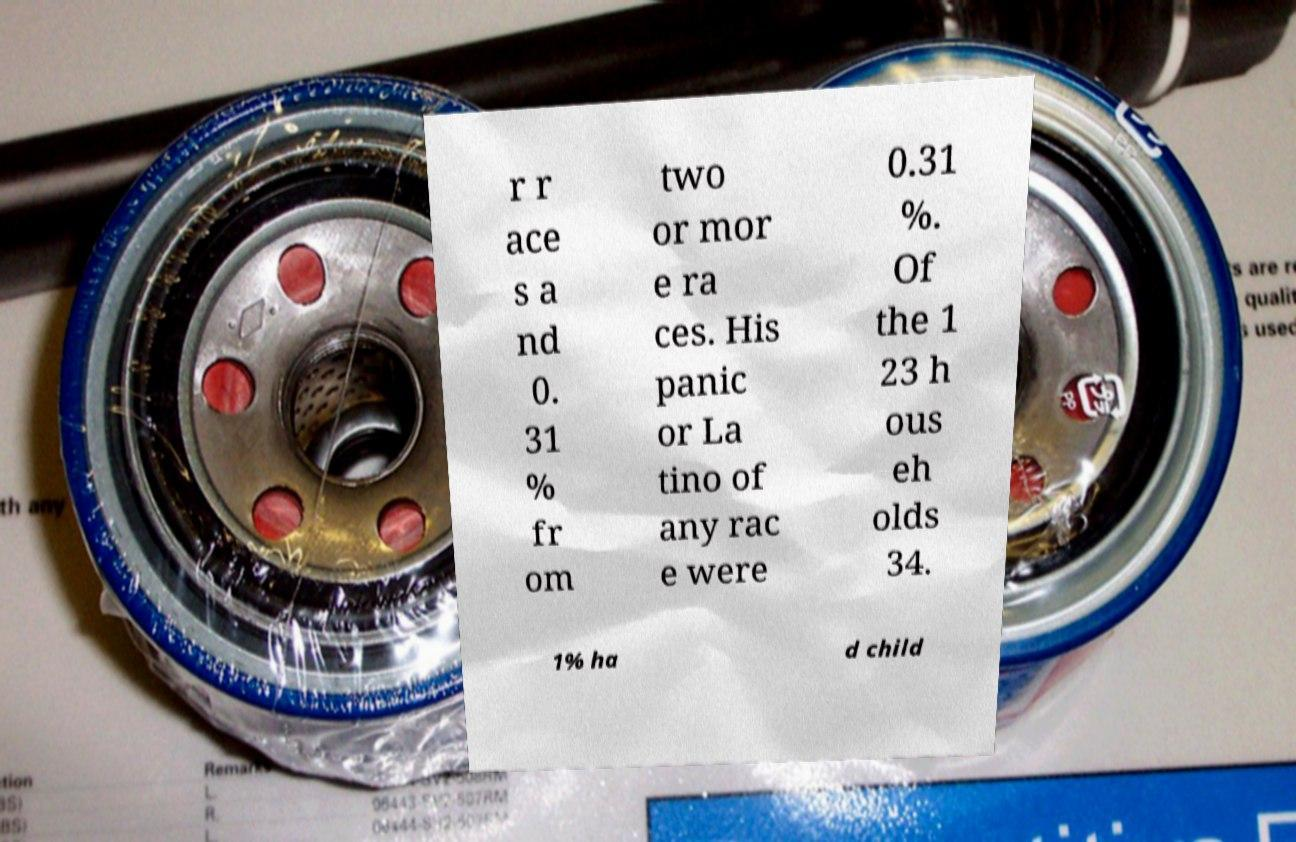For documentation purposes, I need the text within this image transcribed. Could you provide that? r r ace s a nd 0. 31 % fr om two or mor e ra ces. His panic or La tino of any rac e were 0.31 %. Of the 1 23 h ous eh olds 34. 1% ha d child 